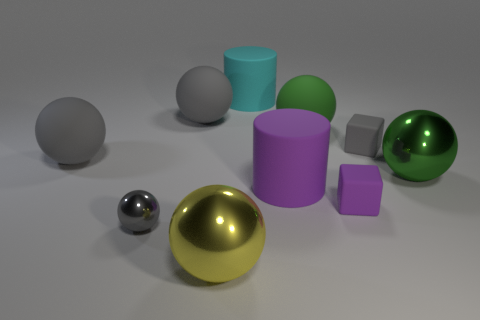Subtract all small gray balls. How many balls are left? 5 Add 6 small purple metal cubes. How many small purple metal cubes exist? 6 Subtract all purple blocks. How many blocks are left? 1 Subtract 0 blue spheres. How many objects are left? 10 Subtract all balls. How many objects are left? 4 Subtract 4 spheres. How many spheres are left? 2 Subtract all yellow blocks. Subtract all purple cylinders. How many blocks are left? 2 Subtract all green spheres. How many red blocks are left? 0 Subtract all large cyan cylinders. Subtract all yellow balls. How many objects are left? 8 Add 3 green metal balls. How many green metal balls are left? 4 